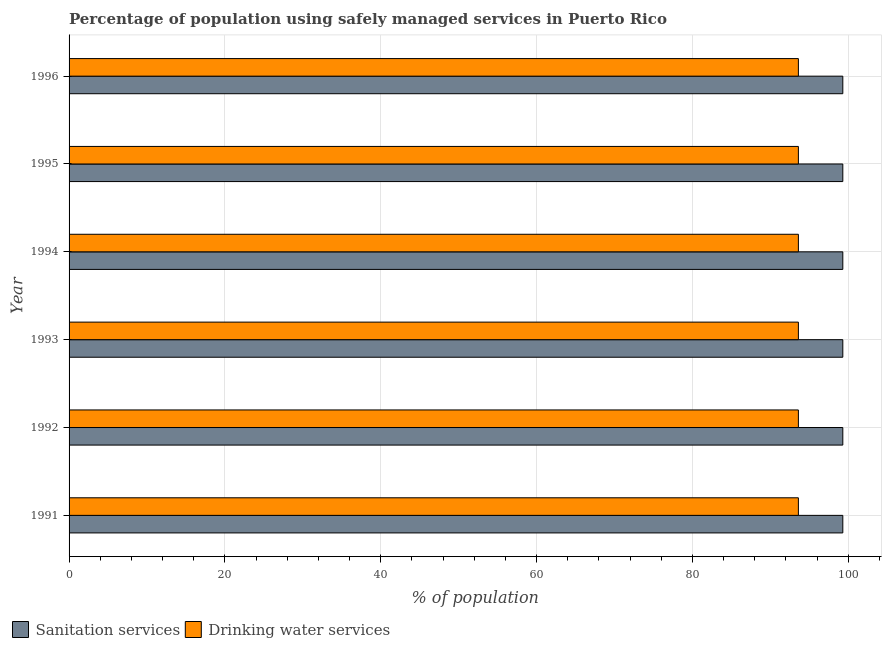How many groups of bars are there?
Provide a short and direct response. 6. Are the number of bars per tick equal to the number of legend labels?
Keep it short and to the point. Yes. Are the number of bars on each tick of the Y-axis equal?
Offer a terse response. Yes. What is the percentage of population who used drinking water services in 1993?
Offer a terse response. 93.6. Across all years, what is the maximum percentage of population who used sanitation services?
Ensure brevity in your answer.  99.3. Across all years, what is the minimum percentage of population who used sanitation services?
Provide a short and direct response. 99.3. What is the total percentage of population who used sanitation services in the graph?
Provide a succinct answer. 595.8. What is the difference between the percentage of population who used drinking water services in 1992 and that in 1995?
Ensure brevity in your answer.  0. What is the difference between the percentage of population who used drinking water services in 1992 and the percentage of population who used sanitation services in 1996?
Ensure brevity in your answer.  -5.7. What is the average percentage of population who used drinking water services per year?
Your response must be concise. 93.6. In how many years, is the percentage of population who used sanitation services greater than 40 %?
Give a very brief answer. 6. What does the 2nd bar from the top in 1993 represents?
Provide a short and direct response. Sanitation services. What does the 1st bar from the bottom in 1994 represents?
Offer a terse response. Sanitation services. How many bars are there?
Provide a succinct answer. 12. Are all the bars in the graph horizontal?
Make the answer very short. Yes. What is the difference between two consecutive major ticks on the X-axis?
Keep it short and to the point. 20. Are the values on the major ticks of X-axis written in scientific E-notation?
Your answer should be compact. No. Does the graph contain any zero values?
Ensure brevity in your answer.  No. Does the graph contain grids?
Provide a succinct answer. Yes. How many legend labels are there?
Keep it short and to the point. 2. How are the legend labels stacked?
Provide a short and direct response. Horizontal. What is the title of the graph?
Your answer should be compact. Percentage of population using safely managed services in Puerto Rico. What is the label or title of the X-axis?
Your response must be concise. % of population. What is the % of population of Sanitation services in 1991?
Your answer should be compact. 99.3. What is the % of population in Drinking water services in 1991?
Ensure brevity in your answer.  93.6. What is the % of population in Sanitation services in 1992?
Provide a short and direct response. 99.3. What is the % of population of Drinking water services in 1992?
Provide a short and direct response. 93.6. What is the % of population in Sanitation services in 1993?
Your response must be concise. 99.3. What is the % of population in Drinking water services in 1993?
Your answer should be very brief. 93.6. What is the % of population of Sanitation services in 1994?
Ensure brevity in your answer.  99.3. What is the % of population in Drinking water services in 1994?
Offer a terse response. 93.6. What is the % of population in Sanitation services in 1995?
Provide a short and direct response. 99.3. What is the % of population of Drinking water services in 1995?
Make the answer very short. 93.6. What is the % of population of Sanitation services in 1996?
Make the answer very short. 99.3. What is the % of population of Drinking water services in 1996?
Offer a very short reply. 93.6. Across all years, what is the maximum % of population of Sanitation services?
Offer a very short reply. 99.3. Across all years, what is the maximum % of population of Drinking water services?
Provide a succinct answer. 93.6. Across all years, what is the minimum % of population of Sanitation services?
Give a very brief answer. 99.3. Across all years, what is the minimum % of population of Drinking water services?
Keep it short and to the point. 93.6. What is the total % of population in Sanitation services in the graph?
Make the answer very short. 595.8. What is the total % of population in Drinking water services in the graph?
Give a very brief answer. 561.6. What is the difference between the % of population in Drinking water services in 1991 and that in 1992?
Your answer should be compact. 0. What is the difference between the % of population in Sanitation services in 1991 and that in 1993?
Your answer should be compact. 0. What is the difference between the % of population in Sanitation services in 1991 and that in 1994?
Your response must be concise. 0. What is the difference between the % of population of Sanitation services in 1991 and that in 1996?
Give a very brief answer. 0. What is the difference between the % of population in Sanitation services in 1992 and that in 1993?
Make the answer very short. 0. What is the difference between the % of population of Sanitation services in 1992 and that in 1994?
Your answer should be compact. 0. What is the difference between the % of population of Drinking water services in 1992 and that in 1994?
Give a very brief answer. 0. What is the difference between the % of population of Drinking water services in 1992 and that in 1995?
Offer a terse response. 0. What is the difference between the % of population of Sanitation services in 1993 and that in 1996?
Your answer should be compact. 0. What is the difference between the % of population of Sanitation services in 1994 and that in 1995?
Provide a succinct answer. 0. What is the difference between the % of population in Drinking water services in 1994 and that in 1996?
Make the answer very short. 0. What is the difference between the % of population of Sanitation services in 1991 and the % of population of Drinking water services in 1993?
Your response must be concise. 5.7. What is the difference between the % of population in Sanitation services in 1992 and the % of population in Drinking water services in 1996?
Your answer should be very brief. 5.7. What is the difference between the % of population in Sanitation services in 1993 and the % of population in Drinking water services in 1994?
Keep it short and to the point. 5.7. What is the difference between the % of population in Sanitation services in 1993 and the % of population in Drinking water services in 1995?
Your answer should be very brief. 5.7. What is the difference between the % of population in Sanitation services in 1993 and the % of population in Drinking water services in 1996?
Give a very brief answer. 5.7. What is the difference between the % of population of Sanitation services in 1994 and the % of population of Drinking water services in 1995?
Provide a succinct answer. 5.7. What is the difference between the % of population of Sanitation services in 1994 and the % of population of Drinking water services in 1996?
Your answer should be compact. 5.7. What is the difference between the % of population in Sanitation services in 1995 and the % of population in Drinking water services in 1996?
Ensure brevity in your answer.  5.7. What is the average % of population of Sanitation services per year?
Provide a short and direct response. 99.3. What is the average % of population of Drinking water services per year?
Ensure brevity in your answer.  93.6. In the year 1991, what is the difference between the % of population in Sanitation services and % of population in Drinking water services?
Provide a succinct answer. 5.7. In the year 1994, what is the difference between the % of population in Sanitation services and % of population in Drinking water services?
Make the answer very short. 5.7. In the year 1995, what is the difference between the % of population of Sanitation services and % of population of Drinking water services?
Keep it short and to the point. 5.7. In the year 1996, what is the difference between the % of population of Sanitation services and % of population of Drinking water services?
Your answer should be very brief. 5.7. What is the ratio of the % of population in Sanitation services in 1991 to that in 1993?
Keep it short and to the point. 1. What is the ratio of the % of population in Drinking water services in 1991 to that in 1993?
Give a very brief answer. 1. What is the ratio of the % of population of Sanitation services in 1991 to that in 1996?
Provide a short and direct response. 1. What is the ratio of the % of population of Drinking water services in 1991 to that in 1996?
Make the answer very short. 1. What is the ratio of the % of population of Sanitation services in 1992 to that in 1994?
Give a very brief answer. 1. What is the ratio of the % of population of Drinking water services in 1992 to that in 1994?
Your answer should be very brief. 1. What is the ratio of the % of population of Sanitation services in 1992 to that in 1996?
Your response must be concise. 1. What is the ratio of the % of population in Drinking water services in 1992 to that in 1996?
Keep it short and to the point. 1. What is the ratio of the % of population in Sanitation services in 1993 to that in 1996?
Provide a short and direct response. 1. What is the ratio of the % of population of Drinking water services in 1995 to that in 1996?
Provide a succinct answer. 1. What is the difference between the highest and the second highest % of population in Sanitation services?
Offer a terse response. 0. What is the difference between the highest and the second highest % of population of Drinking water services?
Your answer should be very brief. 0. 